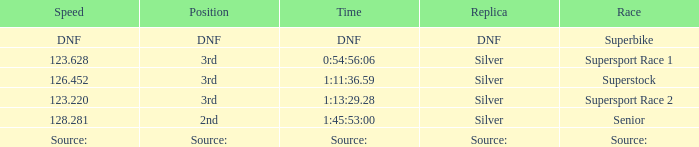Which position has a speed of 123.220? 3rd. 